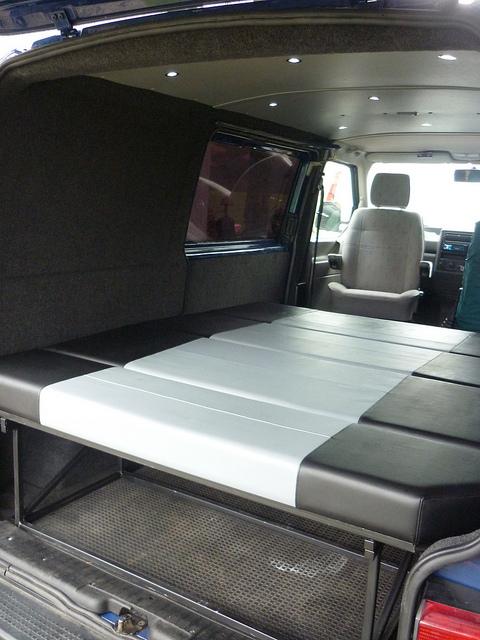How many seats are there?
Concise answer only. 1. What type of vehicle is this?
Quick response, please. Van. Is the chair facing the camera?
Quick response, please. Yes. 